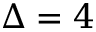Convert formula to latex. <formula><loc_0><loc_0><loc_500><loc_500>\Delta = 4</formula> 